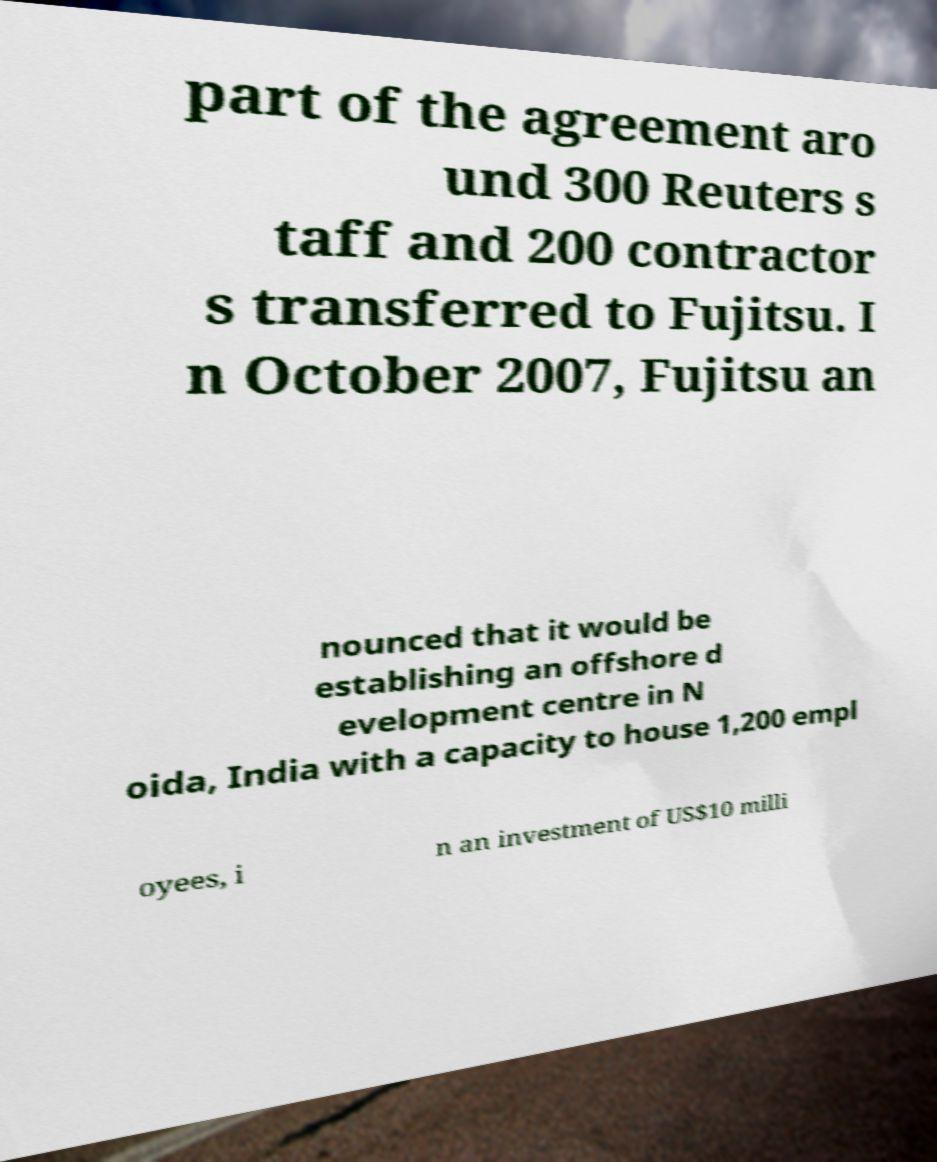Could you assist in decoding the text presented in this image and type it out clearly? part of the agreement aro und 300 Reuters s taff and 200 contractor s transferred to Fujitsu. I n October 2007, Fujitsu an nounced that it would be establishing an offshore d evelopment centre in N oida, India with a capacity to house 1,200 empl oyees, i n an investment of US$10 milli 